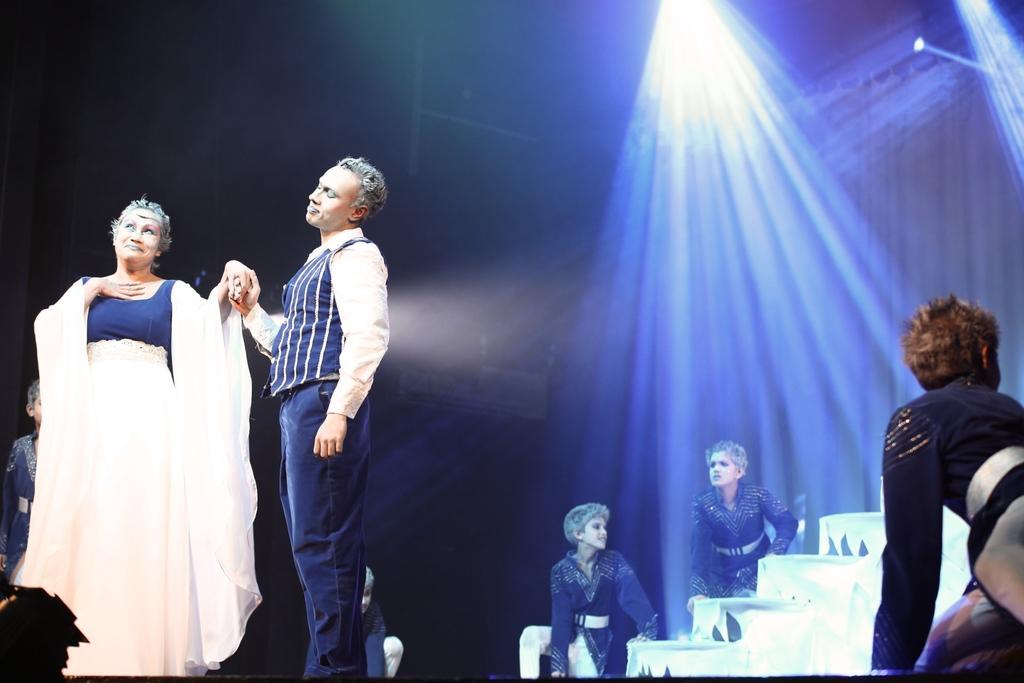Can you describe this image briefly? There are two persons standing on the left side is dancing and there are some persons in the background. There are some lights arranged at the top of this image. 